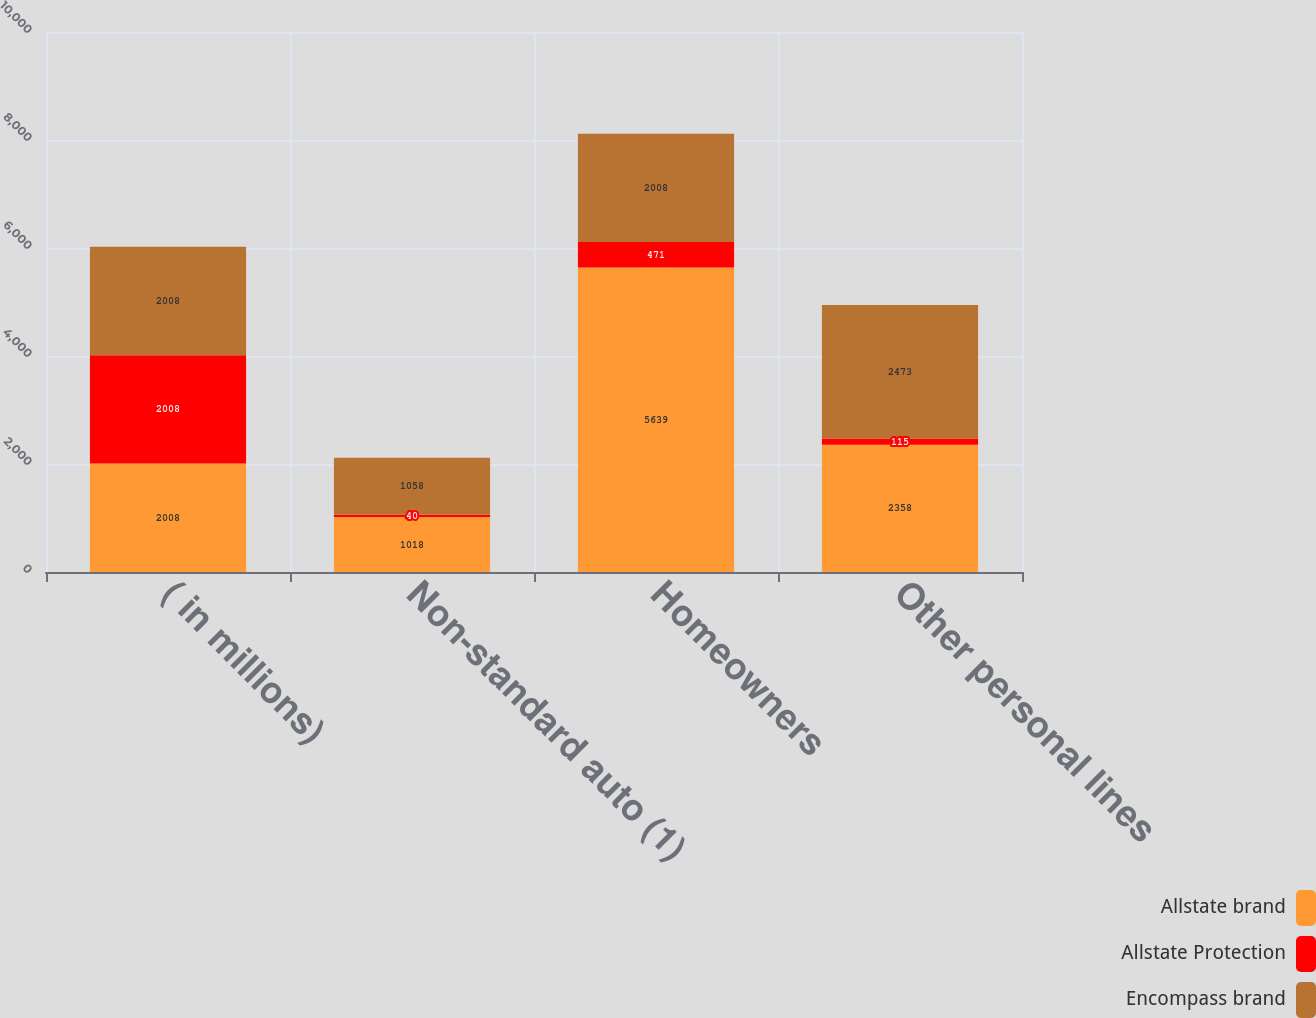Convert chart. <chart><loc_0><loc_0><loc_500><loc_500><stacked_bar_chart><ecel><fcel>( in millions)<fcel>Non-standard auto (1)<fcel>Homeowners<fcel>Other personal lines<nl><fcel>Allstate brand<fcel>2008<fcel>1018<fcel>5639<fcel>2358<nl><fcel>Allstate Protection<fcel>2008<fcel>40<fcel>471<fcel>115<nl><fcel>Encompass brand<fcel>2008<fcel>1058<fcel>2008<fcel>2473<nl></chart> 